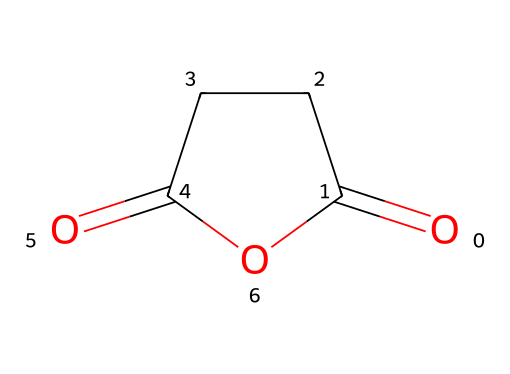How many carbon atoms are in succinic anhydride? The SMILES representation indicates there are four carbon atoms present in the structure (C1CCC). Each 'C' denotes a carbon atom, and there are four in total.
Answer: four What functional groups are present in succinic anhydride? The structure contains two carbonyl groups (C=O) due to the presence of O=C and CCC(=O), and also contains an anhydride linkage. The combination of these indicates the presence of carboxylic acid anhydride functional groups.
Answer: carbonyl and anhydride What is the empirical formula of succinic anhydride? Counting the atoms from the SMILES, there are 4 carbons, 4 hydrogens, and 3 oxygens, leading to the empirical formula C4H4O3.
Answer: C4H4O3 How many cyclic structures are present in succinic anhydride? The structure is cyclic, denoted by the presence of C1 and O1, indicating that it forms a ring. Thus, there is one cyclic structure.
Answer: one What type of reaction could succinic anhydride be involved in? Succinic anhydride can participate in hydrolysis, which is when it reacts with water to form succinic acid. This falls under addition reactions typical for anhydrides.
Answer: hydrolysis What is the significance of the anhydride bond in this compound? The anhydride bond creates a linkage between carbonyl groups, enabling the molecule to undergo reactions that can lead to polymerization, which is valuable in biodegradable plastics.
Answer: enables polymerization Is succinic anhydride classified as a saturated or unsaturated compound? Anhydrides typically contain multiple bonds, in this case, there are double bonds (C=O), classifying succinic anhydride as unsaturated.
Answer: unsaturated 